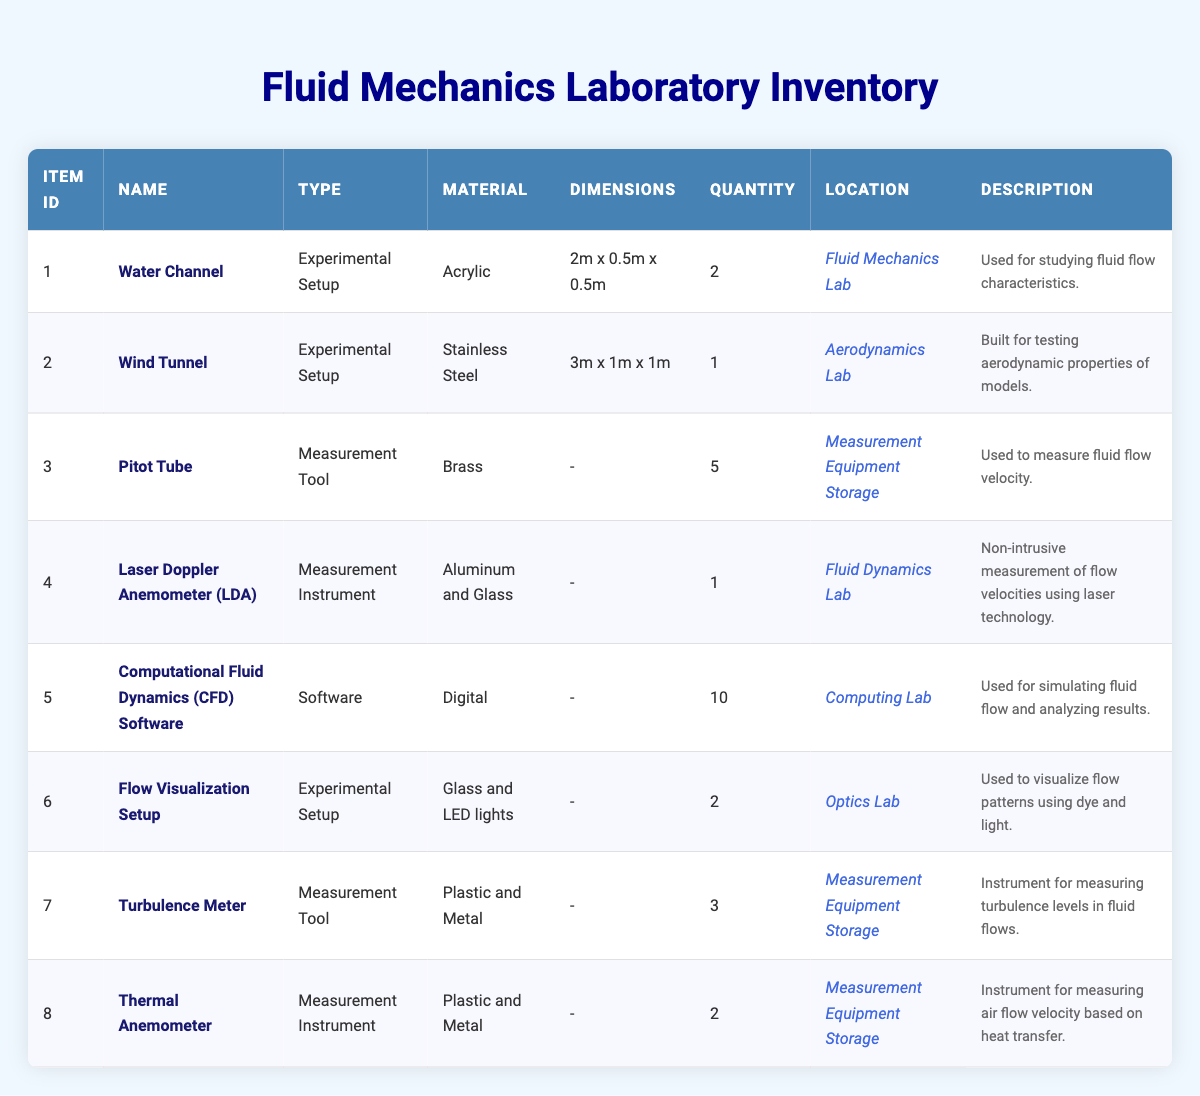What is the total quantity of measurement tools available in the inventory? The inventory consists of three measurement tools: Pitot Tube (5), Turbulence Meter (3), and Thermal Anemometer (2). Adding these quantities gives a total of 5 + 3 + 2 = 10 measurement tools.
Answer: 10 In which lab is the Laser Doppler Anemometer located? The table specifies that the Laser Doppler Anemometer (LDA) is stored in the Fluid Dynamics Lab.
Answer: Fluid Dynamics Lab How many Experimental Setups are identified in the inventory? The inventory lists three Experimental Setups: Water Channel (2), Wind Tunnel (1), and Flow Visualization Setup (2). Therefore, the count is 3.
Answer: 3 Is the Wind Tunnel made of Plastic? The material of the Wind Tunnel is specified as Stainless Steel, which means the statement is false.
Answer: No What is the average quantity of items across all types of equipment? The total quantity of items listed is 2 (Water Channel) + 1 (Wind Tunnel) + 5 (Pitot Tube) + 1 (LDA) + 10 (CFD Software) + 2 (Flow Visualization Setup) + 3 (Turbulence Meter) + 2 (Thermal Anemometer) = 26. Since there are 8 items, the average is 26/8 = 3.25.
Answer: 3.25 Which type of equipment has the highest quantity, and what is that quantity? The equipment type with the highest quantity is the CFD Software, with a total of 10 units. Therefore, it is determined that the CFD Software has the highest quantity.
Answer: CFD Software, 10 How many more units of the Pitot Tube are there compared to the Thermal Anemometer? There are 5 units of the Pitot Tube and 2 units of the Thermal Anemometer. The difference is calculated as 5 - 2 = 3, which indicates there are 3 more units of the Pitot Tube.
Answer: 3 Are there any items in the inventory made of Glass? The inventory lists two items that include Glass as a material: the Laser Doppler Anemometer (Aluminum and Glass) and the Flow Visualization Setup (Glass and LED lights), confirming that the statement is true.
Answer: Yes What is the total number of items stored in the Measurement Equipment Storage? According to the table, the total number of items in Measurement Equipment Storage includes the Pitot Tube (5), Turbulence Meter (3), and Thermal Anemometer (2). Summing these gives 5 + 3 + 2 = 10 items stored in that location.
Answer: 10 